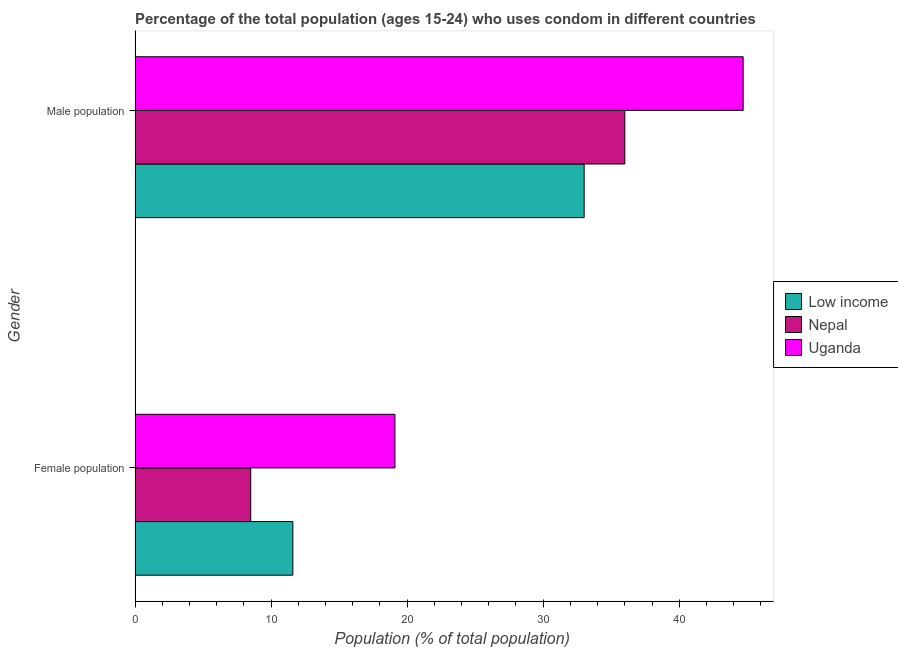How many different coloured bars are there?
Your answer should be compact. 3. How many groups of bars are there?
Your answer should be compact. 2. How many bars are there on the 1st tick from the bottom?
Provide a succinct answer. 3. What is the label of the 1st group of bars from the top?
Your response must be concise. Male population. What is the male population in Low income?
Make the answer very short. 33.01. Across all countries, what is the maximum male population?
Give a very brief answer. 44.7. In which country was the male population maximum?
Ensure brevity in your answer.  Uganda. In which country was the female population minimum?
Your answer should be very brief. Nepal. What is the total male population in the graph?
Give a very brief answer. 113.71. What is the difference between the male population in Uganda and that in Nepal?
Offer a very short reply. 8.7. What is the difference between the male population in Uganda and the female population in Nepal?
Ensure brevity in your answer.  36.2. What is the average male population per country?
Provide a succinct answer. 37.9. In how many countries, is the male population greater than 22 %?
Make the answer very short. 3. What is the ratio of the female population in Low income to that in Uganda?
Make the answer very short. 0.61. Is the male population in Nepal less than that in Uganda?
Your answer should be compact. Yes. What does the 1st bar from the top in Male population represents?
Your answer should be compact. Uganda. What does the 1st bar from the bottom in Male population represents?
Give a very brief answer. Low income. How many bars are there?
Give a very brief answer. 6. Are all the bars in the graph horizontal?
Offer a very short reply. Yes. How many countries are there in the graph?
Your answer should be very brief. 3. Are the values on the major ticks of X-axis written in scientific E-notation?
Provide a short and direct response. No. Where does the legend appear in the graph?
Your response must be concise. Center right. How are the legend labels stacked?
Provide a short and direct response. Vertical. What is the title of the graph?
Offer a terse response. Percentage of the total population (ages 15-24) who uses condom in different countries. What is the label or title of the X-axis?
Offer a terse response. Population (% of total population) . What is the Population (% of total population)  of Low income in Female population?
Your response must be concise. 11.6. What is the Population (% of total population)  of Nepal in Female population?
Offer a very short reply. 8.5. What is the Population (% of total population)  in Low income in Male population?
Keep it short and to the point. 33.01. What is the Population (% of total population)  in Nepal in Male population?
Make the answer very short. 36. What is the Population (% of total population)  of Uganda in Male population?
Your response must be concise. 44.7. Across all Gender, what is the maximum Population (% of total population)  of Low income?
Your answer should be compact. 33.01. Across all Gender, what is the maximum Population (% of total population)  in Nepal?
Give a very brief answer. 36. Across all Gender, what is the maximum Population (% of total population)  in Uganda?
Make the answer very short. 44.7. Across all Gender, what is the minimum Population (% of total population)  of Low income?
Provide a succinct answer. 11.6. What is the total Population (% of total population)  of Low income in the graph?
Make the answer very short. 44.61. What is the total Population (% of total population)  of Nepal in the graph?
Keep it short and to the point. 44.5. What is the total Population (% of total population)  of Uganda in the graph?
Give a very brief answer. 63.8. What is the difference between the Population (% of total population)  of Low income in Female population and that in Male population?
Make the answer very short. -21.42. What is the difference between the Population (% of total population)  in Nepal in Female population and that in Male population?
Keep it short and to the point. -27.5. What is the difference between the Population (% of total population)  in Uganda in Female population and that in Male population?
Your answer should be compact. -25.6. What is the difference between the Population (% of total population)  in Low income in Female population and the Population (% of total population)  in Nepal in Male population?
Your answer should be very brief. -24.4. What is the difference between the Population (% of total population)  of Low income in Female population and the Population (% of total population)  of Uganda in Male population?
Make the answer very short. -33.1. What is the difference between the Population (% of total population)  in Nepal in Female population and the Population (% of total population)  in Uganda in Male population?
Offer a terse response. -36.2. What is the average Population (% of total population)  of Low income per Gender?
Your answer should be compact. 22.3. What is the average Population (% of total population)  of Nepal per Gender?
Your answer should be compact. 22.25. What is the average Population (% of total population)  of Uganda per Gender?
Keep it short and to the point. 31.9. What is the difference between the Population (% of total population)  of Low income and Population (% of total population)  of Nepal in Female population?
Your answer should be compact. 3.1. What is the difference between the Population (% of total population)  of Low income and Population (% of total population)  of Uganda in Female population?
Ensure brevity in your answer.  -7.5. What is the difference between the Population (% of total population)  in Low income and Population (% of total population)  in Nepal in Male population?
Make the answer very short. -2.99. What is the difference between the Population (% of total population)  in Low income and Population (% of total population)  in Uganda in Male population?
Keep it short and to the point. -11.69. What is the ratio of the Population (% of total population)  of Low income in Female population to that in Male population?
Give a very brief answer. 0.35. What is the ratio of the Population (% of total population)  of Nepal in Female population to that in Male population?
Your answer should be compact. 0.24. What is the ratio of the Population (% of total population)  of Uganda in Female population to that in Male population?
Offer a terse response. 0.43. What is the difference between the highest and the second highest Population (% of total population)  in Low income?
Ensure brevity in your answer.  21.42. What is the difference between the highest and the second highest Population (% of total population)  of Uganda?
Ensure brevity in your answer.  25.6. What is the difference between the highest and the lowest Population (% of total population)  of Low income?
Offer a very short reply. 21.42. What is the difference between the highest and the lowest Population (% of total population)  in Nepal?
Offer a very short reply. 27.5. What is the difference between the highest and the lowest Population (% of total population)  of Uganda?
Provide a short and direct response. 25.6. 